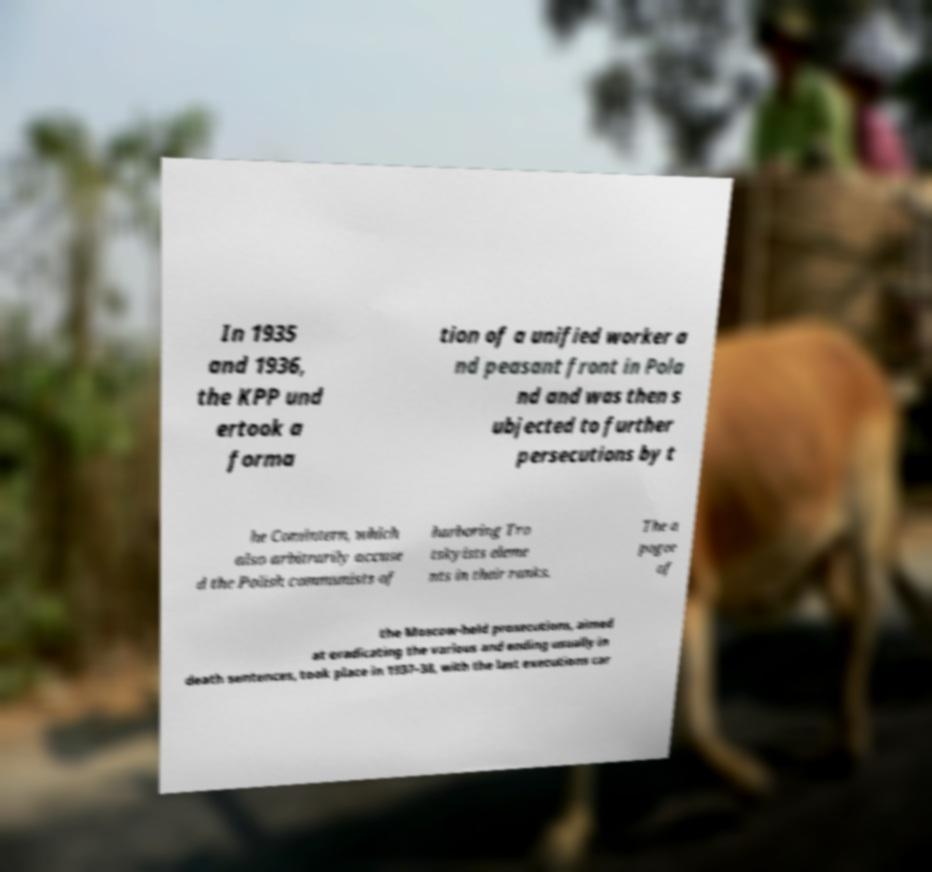There's text embedded in this image that I need extracted. Can you transcribe it verbatim? In 1935 and 1936, the KPP und ertook a forma tion of a unified worker a nd peasant front in Pola nd and was then s ubjected to further persecutions by t he Comintern, which also arbitrarily accuse d the Polish communists of harboring Tro tskyists eleme nts in their ranks. The a pogee of the Moscow-held prosecutions, aimed at eradicating the various and ending usually in death sentences, took place in 1937–38, with the last executions car 